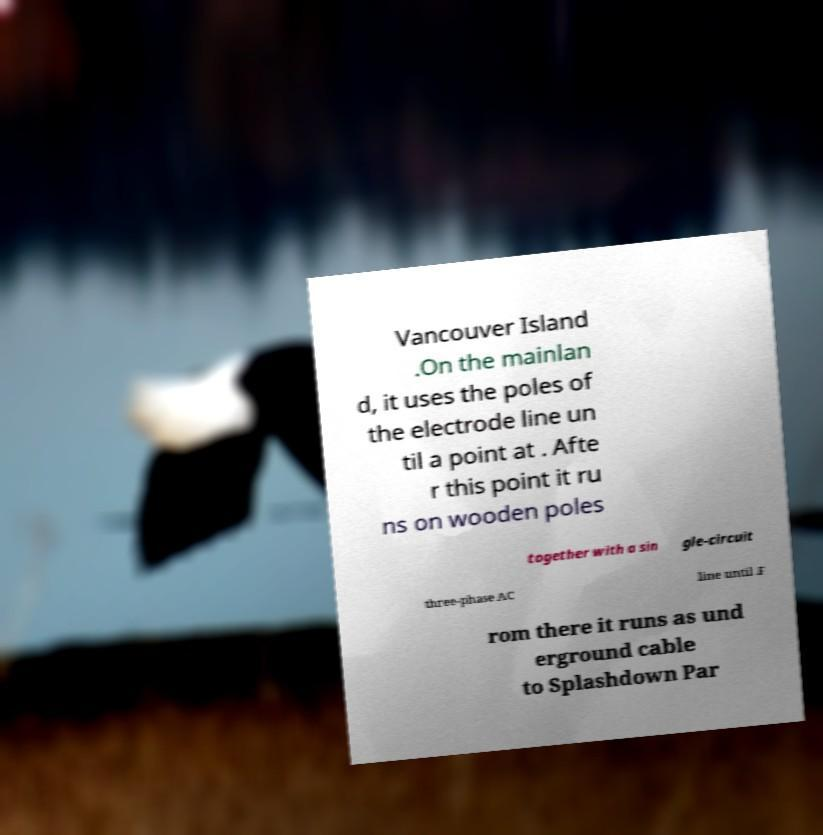Can you read and provide the text displayed in the image?This photo seems to have some interesting text. Can you extract and type it out for me? Vancouver Island .On the mainlan d, it uses the poles of the electrode line un til a point at . Afte r this point it ru ns on wooden poles together with a sin gle-circuit three-phase AC line until .F rom there it runs as und erground cable to Splashdown Par 